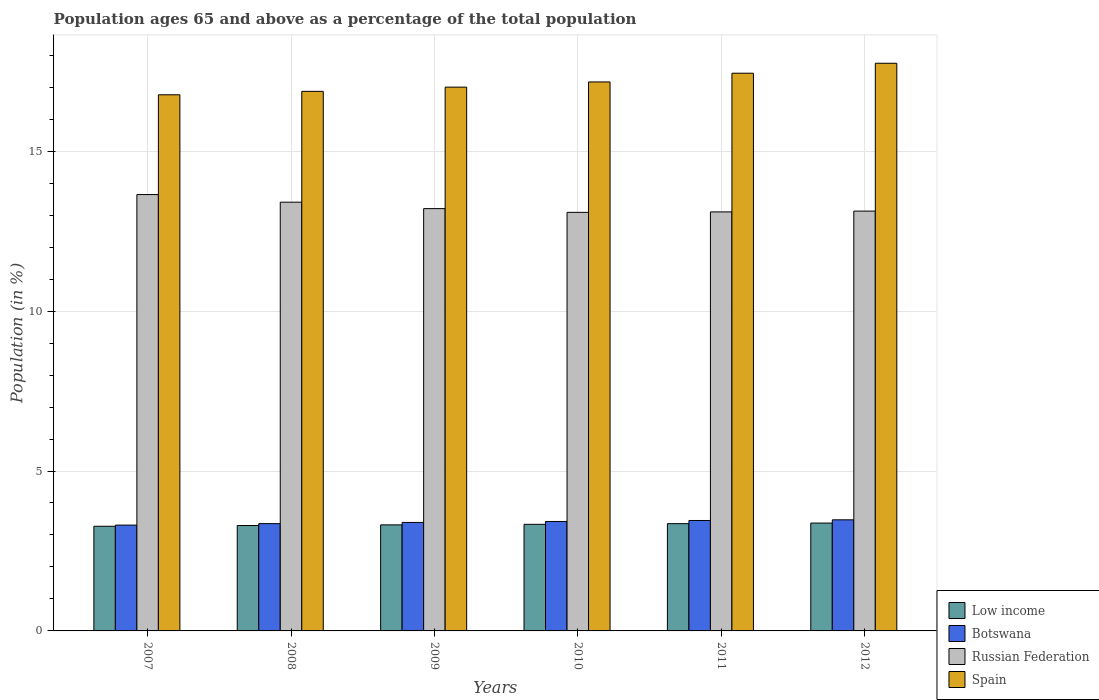How many different coloured bars are there?
Keep it short and to the point. 4. How many groups of bars are there?
Ensure brevity in your answer.  6. How many bars are there on the 5th tick from the left?
Provide a short and direct response. 4. What is the percentage of the population ages 65 and above in Spain in 2007?
Provide a short and direct response. 16.76. Across all years, what is the maximum percentage of the population ages 65 and above in Spain?
Your answer should be compact. 17.75. Across all years, what is the minimum percentage of the population ages 65 and above in Spain?
Ensure brevity in your answer.  16.76. In which year was the percentage of the population ages 65 and above in Low income maximum?
Offer a very short reply. 2012. What is the total percentage of the population ages 65 and above in Botswana in the graph?
Your answer should be very brief. 20.4. What is the difference between the percentage of the population ages 65 and above in Low income in 2007 and that in 2012?
Provide a succinct answer. -0.1. What is the difference between the percentage of the population ages 65 and above in Spain in 2010 and the percentage of the population ages 65 and above in Russian Federation in 2009?
Your answer should be very brief. 3.96. What is the average percentage of the population ages 65 and above in Spain per year?
Make the answer very short. 17.16. In the year 2008, what is the difference between the percentage of the population ages 65 and above in Russian Federation and percentage of the population ages 65 and above in Low income?
Your response must be concise. 10.11. What is the ratio of the percentage of the population ages 65 and above in Botswana in 2008 to that in 2011?
Ensure brevity in your answer.  0.97. What is the difference between the highest and the second highest percentage of the population ages 65 and above in Spain?
Make the answer very short. 0.31. What is the difference between the highest and the lowest percentage of the population ages 65 and above in Russian Federation?
Make the answer very short. 0.56. In how many years, is the percentage of the population ages 65 and above in Spain greater than the average percentage of the population ages 65 and above in Spain taken over all years?
Offer a very short reply. 3. What does the 2nd bar from the right in 2007 represents?
Give a very brief answer. Russian Federation. Is it the case that in every year, the sum of the percentage of the population ages 65 and above in Spain and percentage of the population ages 65 and above in Low income is greater than the percentage of the population ages 65 and above in Botswana?
Make the answer very short. Yes. How many legend labels are there?
Your answer should be compact. 4. How are the legend labels stacked?
Give a very brief answer. Vertical. What is the title of the graph?
Provide a succinct answer. Population ages 65 and above as a percentage of the total population. What is the Population (in %) in Low income in 2007?
Make the answer very short. 3.27. What is the Population (in %) of Botswana in 2007?
Make the answer very short. 3.31. What is the Population (in %) in Russian Federation in 2007?
Make the answer very short. 13.64. What is the Population (in %) of Spain in 2007?
Offer a terse response. 16.76. What is the Population (in %) of Low income in 2008?
Provide a succinct answer. 3.3. What is the Population (in %) in Botswana in 2008?
Provide a succinct answer. 3.35. What is the Population (in %) of Russian Federation in 2008?
Provide a succinct answer. 13.41. What is the Population (in %) of Spain in 2008?
Your answer should be very brief. 16.87. What is the Population (in %) of Low income in 2009?
Offer a terse response. 3.32. What is the Population (in %) in Botswana in 2009?
Your answer should be compact. 3.39. What is the Population (in %) in Russian Federation in 2009?
Keep it short and to the point. 13.2. What is the Population (in %) in Spain in 2009?
Your answer should be compact. 17. What is the Population (in %) of Low income in 2010?
Your answer should be compact. 3.33. What is the Population (in %) of Botswana in 2010?
Your answer should be very brief. 3.42. What is the Population (in %) in Russian Federation in 2010?
Give a very brief answer. 13.09. What is the Population (in %) in Spain in 2010?
Give a very brief answer. 17.16. What is the Population (in %) of Low income in 2011?
Provide a succinct answer. 3.35. What is the Population (in %) of Botswana in 2011?
Keep it short and to the point. 3.45. What is the Population (in %) of Russian Federation in 2011?
Your answer should be very brief. 13.1. What is the Population (in %) in Spain in 2011?
Your answer should be compact. 17.44. What is the Population (in %) in Low income in 2012?
Ensure brevity in your answer.  3.37. What is the Population (in %) in Botswana in 2012?
Your answer should be very brief. 3.47. What is the Population (in %) of Russian Federation in 2012?
Your answer should be very brief. 13.13. What is the Population (in %) of Spain in 2012?
Offer a terse response. 17.75. Across all years, what is the maximum Population (in %) of Low income?
Offer a very short reply. 3.37. Across all years, what is the maximum Population (in %) of Botswana?
Ensure brevity in your answer.  3.47. Across all years, what is the maximum Population (in %) of Russian Federation?
Offer a terse response. 13.64. Across all years, what is the maximum Population (in %) in Spain?
Your answer should be very brief. 17.75. Across all years, what is the minimum Population (in %) in Low income?
Provide a short and direct response. 3.27. Across all years, what is the minimum Population (in %) in Botswana?
Your answer should be very brief. 3.31. Across all years, what is the minimum Population (in %) of Russian Federation?
Your response must be concise. 13.09. Across all years, what is the minimum Population (in %) of Spain?
Keep it short and to the point. 16.76. What is the total Population (in %) in Low income in the graph?
Provide a succinct answer. 19.94. What is the total Population (in %) of Botswana in the graph?
Your answer should be compact. 20.4. What is the total Population (in %) of Russian Federation in the graph?
Provide a succinct answer. 79.57. What is the total Population (in %) of Spain in the graph?
Offer a terse response. 102.99. What is the difference between the Population (in %) of Low income in 2007 and that in 2008?
Your response must be concise. -0.02. What is the difference between the Population (in %) in Botswana in 2007 and that in 2008?
Ensure brevity in your answer.  -0.05. What is the difference between the Population (in %) in Russian Federation in 2007 and that in 2008?
Ensure brevity in your answer.  0.24. What is the difference between the Population (in %) of Spain in 2007 and that in 2008?
Offer a very short reply. -0.11. What is the difference between the Population (in %) of Low income in 2007 and that in 2009?
Provide a short and direct response. -0.04. What is the difference between the Population (in %) in Botswana in 2007 and that in 2009?
Offer a very short reply. -0.08. What is the difference between the Population (in %) in Russian Federation in 2007 and that in 2009?
Offer a very short reply. 0.44. What is the difference between the Population (in %) of Spain in 2007 and that in 2009?
Your answer should be compact. -0.24. What is the difference between the Population (in %) of Low income in 2007 and that in 2010?
Provide a short and direct response. -0.06. What is the difference between the Population (in %) of Botswana in 2007 and that in 2010?
Give a very brief answer. -0.11. What is the difference between the Population (in %) of Russian Federation in 2007 and that in 2010?
Make the answer very short. 0.56. What is the difference between the Population (in %) of Spain in 2007 and that in 2010?
Offer a very short reply. -0.4. What is the difference between the Population (in %) of Low income in 2007 and that in 2011?
Your response must be concise. -0.08. What is the difference between the Population (in %) in Botswana in 2007 and that in 2011?
Your response must be concise. -0.14. What is the difference between the Population (in %) of Russian Federation in 2007 and that in 2011?
Provide a short and direct response. 0.54. What is the difference between the Population (in %) in Spain in 2007 and that in 2011?
Your answer should be very brief. -0.67. What is the difference between the Population (in %) in Low income in 2007 and that in 2012?
Provide a short and direct response. -0.1. What is the difference between the Population (in %) of Botswana in 2007 and that in 2012?
Your answer should be compact. -0.17. What is the difference between the Population (in %) of Russian Federation in 2007 and that in 2012?
Give a very brief answer. 0.52. What is the difference between the Population (in %) of Spain in 2007 and that in 2012?
Offer a very short reply. -0.99. What is the difference between the Population (in %) of Low income in 2008 and that in 2009?
Provide a succinct answer. -0.02. What is the difference between the Population (in %) in Botswana in 2008 and that in 2009?
Your response must be concise. -0.04. What is the difference between the Population (in %) in Russian Federation in 2008 and that in 2009?
Provide a short and direct response. 0.2. What is the difference between the Population (in %) of Spain in 2008 and that in 2009?
Offer a very short reply. -0.13. What is the difference between the Population (in %) in Low income in 2008 and that in 2010?
Ensure brevity in your answer.  -0.04. What is the difference between the Population (in %) of Botswana in 2008 and that in 2010?
Ensure brevity in your answer.  -0.07. What is the difference between the Population (in %) of Russian Federation in 2008 and that in 2010?
Your answer should be very brief. 0.32. What is the difference between the Population (in %) of Spain in 2008 and that in 2010?
Your response must be concise. -0.29. What is the difference between the Population (in %) in Low income in 2008 and that in 2011?
Provide a succinct answer. -0.06. What is the difference between the Population (in %) of Botswana in 2008 and that in 2011?
Your response must be concise. -0.1. What is the difference between the Population (in %) of Russian Federation in 2008 and that in 2011?
Make the answer very short. 0.3. What is the difference between the Population (in %) in Spain in 2008 and that in 2011?
Provide a succinct answer. -0.57. What is the difference between the Population (in %) in Low income in 2008 and that in 2012?
Keep it short and to the point. -0.08. What is the difference between the Population (in %) in Botswana in 2008 and that in 2012?
Provide a succinct answer. -0.12. What is the difference between the Population (in %) in Russian Federation in 2008 and that in 2012?
Your answer should be compact. 0.28. What is the difference between the Population (in %) of Spain in 2008 and that in 2012?
Your response must be concise. -0.88. What is the difference between the Population (in %) of Low income in 2009 and that in 2010?
Offer a very short reply. -0.02. What is the difference between the Population (in %) in Botswana in 2009 and that in 2010?
Provide a succinct answer. -0.03. What is the difference between the Population (in %) of Russian Federation in 2009 and that in 2010?
Your answer should be compact. 0.12. What is the difference between the Population (in %) in Spain in 2009 and that in 2010?
Offer a very short reply. -0.16. What is the difference between the Population (in %) of Low income in 2009 and that in 2011?
Offer a very short reply. -0.04. What is the difference between the Population (in %) in Botswana in 2009 and that in 2011?
Your answer should be compact. -0.06. What is the difference between the Population (in %) of Russian Federation in 2009 and that in 2011?
Your answer should be compact. 0.1. What is the difference between the Population (in %) in Spain in 2009 and that in 2011?
Your answer should be very brief. -0.44. What is the difference between the Population (in %) in Low income in 2009 and that in 2012?
Ensure brevity in your answer.  -0.06. What is the difference between the Population (in %) in Botswana in 2009 and that in 2012?
Your answer should be very brief. -0.08. What is the difference between the Population (in %) in Russian Federation in 2009 and that in 2012?
Provide a short and direct response. 0.08. What is the difference between the Population (in %) of Spain in 2009 and that in 2012?
Offer a terse response. -0.75. What is the difference between the Population (in %) of Low income in 2010 and that in 2011?
Make the answer very short. -0.02. What is the difference between the Population (in %) in Botswana in 2010 and that in 2011?
Provide a short and direct response. -0.03. What is the difference between the Population (in %) of Russian Federation in 2010 and that in 2011?
Your answer should be compact. -0.01. What is the difference between the Population (in %) of Spain in 2010 and that in 2011?
Keep it short and to the point. -0.27. What is the difference between the Population (in %) in Low income in 2010 and that in 2012?
Give a very brief answer. -0.04. What is the difference between the Population (in %) of Botswana in 2010 and that in 2012?
Provide a succinct answer. -0.05. What is the difference between the Population (in %) of Russian Federation in 2010 and that in 2012?
Your answer should be compact. -0.04. What is the difference between the Population (in %) of Spain in 2010 and that in 2012?
Offer a terse response. -0.58. What is the difference between the Population (in %) of Low income in 2011 and that in 2012?
Provide a succinct answer. -0.02. What is the difference between the Population (in %) of Botswana in 2011 and that in 2012?
Make the answer very short. -0.02. What is the difference between the Population (in %) in Russian Federation in 2011 and that in 2012?
Provide a short and direct response. -0.03. What is the difference between the Population (in %) in Spain in 2011 and that in 2012?
Keep it short and to the point. -0.31. What is the difference between the Population (in %) of Low income in 2007 and the Population (in %) of Botswana in 2008?
Offer a very short reply. -0.08. What is the difference between the Population (in %) in Low income in 2007 and the Population (in %) in Russian Federation in 2008?
Provide a short and direct response. -10.13. What is the difference between the Population (in %) of Low income in 2007 and the Population (in %) of Spain in 2008?
Your answer should be very brief. -13.6. What is the difference between the Population (in %) of Botswana in 2007 and the Population (in %) of Russian Federation in 2008?
Offer a terse response. -10.1. What is the difference between the Population (in %) of Botswana in 2007 and the Population (in %) of Spain in 2008?
Ensure brevity in your answer.  -13.56. What is the difference between the Population (in %) of Russian Federation in 2007 and the Population (in %) of Spain in 2008?
Ensure brevity in your answer.  -3.23. What is the difference between the Population (in %) of Low income in 2007 and the Population (in %) of Botswana in 2009?
Give a very brief answer. -0.12. What is the difference between the Population (in %) of Low income in 2007 and the Population (in %) of Russian Federation in 2009?
Your response must be concise. -9.93. What is the difference between the Population (in %) in Low income in 2007 and the Population (in %) in Spain in 2009?
Give a very brief answer. -13.73. What is the difference between the Population (in %) in Botswana in 2007 and the Population (in %) in Russian Federation in 2009?
Offer a terse response. -9.9. What is the difference between the Population (in %) of Botswana in 2007 and the Population (in %) of Spain in 2009?
Offer a very short reply. -13.69. What is the difference between the Population (in %) of Russian Federation in 2007 and the Population (in %) of Spain in 2009?
Give a very brief answer. -3.36. What is the difference between the Population (in %) of Low income in 2007 and the Population (in %) of Botswana in 2010?
Your answer should be very brief. -0.15. What is the difference between the Population (in %) of Low income in 2007 and the Population (in %) of Russian Federation in 2010?
Your response must be concise. -9.81. What is the difference between the Population (in %) of Low income in 2007 and the Population (in %) of Spain in 2010?
Make the answer very short. -13.89. What is the difference between the Population (in %) in Botswana in 2007 and the Population (in %) in Russian Federation in 2010?
Offer a terse response. -9.78. What is the difference between the Population (in %) of Botswana in 2007 and the Population (in %) of Spain in 2010?
Make the answer very short. -13.86. What is the difference between the Population (in %) in Russian Federation in 2007 and the Population (in %) in Spain in 2010?
Your answer should be compact. -3.52. What is the difference between the Population (in %) of Low income in 2007 and the Population (in %) of Botswana in 2011?
Your answer should be compact. -0.18. What is the difference between the Population (in %) in Low income in 2007 and the Population (in %) in Russian Federation in 2011?
Your answer should be compact. -9.83. What is the difference between the Population (in %) of Low income in 2007 and the Population (in %) of Spain in 2011?
Your answer should be compact. -14.17. What is the difference between the Population (in %) of Botswana in 2007 and the Population (in %) of Russian Federation in 2011?
Your answer should be very brief. -9.79. What is the difference between the Population (in %) in Botswana in 2007 and the Population (in %) in Spain in 2011?
Offer a very short reply. -14.13. What is the difference between the Population (in %) of Russian Federation in 2007 and the Population (in %) of Spain in 2011?
Your answer should be compact. -3.79. What is the difference between the Population (in %) in Low income in 2007 and the Population (in %) in Botswana in 2012?
Give a very brief answer. -0.2. What is the difference between the Population (in %) of Low income in 2007 and the Population (in %) of Russian Federation in 2012?
Your answer should be compact. -9.85. What is the difference between the Population (in %) of Low income in 2007 and the Population (in %) of Spain in 2012?
Give a very brief answer. -14.48. What is the difference between the Population (in %) in Botswana in 2007 and the Population (in %) in Russian Federation in 2012?
Your response must be concise. -9.82. What is the difference between the Population (in %) in Botswana in 2007 and the Population (in %) in Spain in 2012?
Offer a terse response. -14.44. What is the difference between the Population (in %) in Russian Federation in 2007 and the Population (in %) in Spain in 2012?
Offer a terse response. -4.11. What is the difference between the Population (in %) in Low income in 2008 and the Population (in %) in Botswana in 2009?
Keep it short and to the point. -0.1. What is the difference between the Population (in %) in Low income in 2008 and the Population (in %) in Russian Federation in 2009?
Give a very brief answer. -9.91. What is the difference between the Population (in %) in Low income in 2008 and the Population (in %) in Spain in 2009?
Keep it short and to the point. -13.71. What is the difference between the Population (in %) of Botswana in 2008 and the Population (in %) of Russian Federation in 2009?
Offer a very short reply. -9.85. What is the difference between the Population (in %) of Botswana in 2008 and the Population (in %) of Spain in 2009?
Offer a terse response. -13.65. What is the difference between the Population (in %) of Russian Federation in 2008 and the Population (in %) of Spain in 2009?
Give a very brief answer. -3.6. What is the difference between the Population (in %) in Low income in 2008 and the Population (in %) in Botswana in 2010?
Your response must be concise. -0.13. What is the difference between the Population (in %) of Low income in 2008 and the Population (in %) of Russian Federation in 2010?
Offer a terse response. -9.79. What is the difference between the Population (in %) in Low income in 2008 and the Population (in %) in Spain in 2010?
Your answer should be very brief. -13.87. What is the difference between the Population (in %) in Botswana in 2008 and the Population (in %) in Russian Federation in 2010?
Your answer should be compact. -9.73. What is the difference between the Population (in %) in Botswana in 2008 and the Population (in %) in Spain in 2010?
Provide a short and direct response. -13.81. What is the difference between the Population (in %) in Russian Federation in 2008 and the Population (in %) in Spain in 2010?
Your response must be concise. -3.76. What is the difference between the Population (in %) of Low income in 2008 and the Population (in %) of Botswana in 2011?
Ensure brevity in your answer.  -0.16. What is the difference between the Population (in %) in Low income in 2008 and the Population (in %) in Russian Federation in 2011?
Offer a terse response. -9.81. What is the difference between the Population (in %) in Low income in 2008 and the Population (in %) in Spain in 2011?
Keep it short and to the point. -14.14. What is the difference between the Population (in %) in Botswana in 2008 and the Population (in %) in Russian Federation in 2011?
Provide a short and direct response. -9.75. What is the difference between the Population (in %) in Botswana in 2008 and the Population (in %) in Spain in 2011?
Make the answer very short. -14.08. What is the difference between the Population (in %) in Russian Federation in 2008 and the Population (in %) in Spain in 2011?
Your answer should be very brief. -4.03. What is the difference between the Population (in %) in Low income in 2008 and the Population (in %) in Botswana in 2012?
Provide a succinct answer. -0.18. What is the difference between the Population (in %) of Low income in 2008 and the Population (in %) of Russian Federation in 2012?
Make the answer very short. -9.83. What is the difference between the Population (in %) in Low income in 2008 and the Population (in %) in Spain in 2012?
Provide a short and direct response. -14.45. What is the difference between the Population (in %) in Botswana in 2008 and the Population (in %) in Russian Federation in 2012?
Offer a very short reply. -9.77. What is the difference between the Population (in %) in Botswana in 2008 and the Population (in %) in Spain in 2012?
Make the answer very short. -14.39. What is the difference between the Population (in %) of Russian Federation in 2008 and the Population (in %) of Spain in 2012?
Make the answer very short. -4.34. What is the difference between the Population (in %) of Low income in 2009 and the Population (in %) of Botswana in 2010?
Your response must be concise. -0.11. What is the difference between the Population (in %) of Low income in 2009 and the Population (in %) of Russian Federation in 2010?
Your response must be concise. -9.77. What is the difference between the Population (in %) of Low income in 2009 and the Population (in %) of Spain in 2010?
Make the answer very short. -13.85. What is the difference between the Population (in %) in Botswana in 2009 and the Population (in %) in Russian Federation in 2010?
Provide a short and direct response. -9.69. What is the difference between the Population (in %) in Botswana in 2009 and the Population (in %) in Spain in 2010?
Ensure brevity in your answer.  -13.77. What is the difference between the Population (in %) of Russian Federation in 2009 and the Population (in %) of Spain in 2010?
Provide a succinct answer. -3.96. What is the difference between the Population (in %) of Low income in 2009 and the Population (in %) of Botswana in 2011?
Your answer should be very brief. -0.14. What is the difference between the Population (in %) in Low income in 2009 and the Population (in %) in Russian Federation in 2011?
Your response must be concise. -9.79. What is the difference between the Population (in %) of Low income in 2009 and the Population (in %) of Spain in 2011?
Make the answer very short. -14.12. What is the difference between the Population (in %) of Botswana in 2009 and the Population (in %) of Russian Federation in 2011?
Make the answer very short. -9.71. What is the difference between the Population (in %) in Botswana in 2009 and the Population (in %) in Spain in 2011?
Provide a short and direct response. -14.05. What is the difference between the Population (in %) of Russian Federation in 2009 and the Population (in %) of Spain in 2011?
Give a very brief answer. -4.23. What is the difference between the Population (in %) of Low income in 2009 and the Population (in %) of Botswana in 2012?
Provide a succinct answer. -0.16. What is the difference between the Population (in %) in Low income in 2009 and the Population (in %) in Russian Federation in 2012?
Provide a short and direct response. -9.81. What is the difference between the Population (in %) of Low income in 2009 and the Population (in %) of Spain in 2012?
Make the answer very short. -14.43. What is the difference between the Population (in %) of Botswana in 2009 and the Population (in %) of Russian Federation in 2012?
Your response must be concise. -9.73. What is the difference between the Population (in %) in Botswana in 2009 and the Population (in %) in Spain in 2012?
Your answer should be compact. -14.36. What is the difference between the Population (in %) of Russian Federation in 2009 and the Population (in %) of Spain in 2012?
Make the answer very short. -4.54. What is the difference between the Population (in %) in Low income in 2010 and the Population (in %) in Botswana in 2011?
Offer a terse response. -0.12. What is the difference between the Population (in %) of Low income in 2010 and the Population (in %) of Russian Federation in 2011?
Keep it short and to the point. -9.77. What is the difference between the Population (in %) in Low income in 2010 and the Population (in %) in Spain in 2011?
Provide a succinct answer. -14.1. What is the difference between the Population (in %) in Botswana in 2010 and the Population (in %) in Russian Federation in 2011?
Offer a terse response. -9.68. What is the difference between the Population (in %) of Botswana in 2010 and the Population (in %) of Spain in 2011?
Offer a terse response. -14.02. What is the difference between the Population (in %) of Russian Federation in 2010 and the Population (in %) of Spain in 2011?
Make the answer very short. -4.35. What is the difference between the Population (in %) in Low income in 2010 and the Population (in %) in Botswana in 2012?
Your answer should be very brief. -0.14. What is the difference between the Population (in %) in Low income in 2010 and the Population (in %) in Russian Federation in 2012?
Make the answer very short. -9.79. What is the difference between the Population (in %) in Low income in 2010 and the Population (in %) in Spain in 2012?
Make the answer very short. -14.42. What is the difference between the Population (in %) of Botswana in 2010 and the Population (in %) of Russian Federation in 2012?
Make the answer very short. -9.7. What is the difference between the Population (in %) of Botswana in 2010 and the Population (in %) of Spain in 2012?
Make the answer very short. -14.33. What is the difference between the Population (in %) in Russian Federation in 2010 and the Population (in %) in Spain in 2012?
Give a very brief answer. -4.66. What is the difference between the Population (in %) of Low income in 2011 and the Population (in %) of Botswana in 2012?
Your answer should be very brief. -0.12. What is the difference between the Population (in %) in Low income in 2011 and the Population (in %) in Russian Federation in 2012?
Keep it short and to the point. -9.77. What is the difference between the Population (in %) in Low income in 2011 and the Population (in %) in Spain in 2012?
Provide a short and direct response. -14.39. What is the difference between the Population (in %) of Botswana in 2011 and the Population (in %) of Russian Federation in 2012?
Ensure brevity in your answer.  -9.67. What is the difference between the Population (in %) of Botswana in 2011 and the Population (in %) of Spain in 2012?
Your answer should be very brief. -14.3. What is the difference between the Population (in %) in Russian Federation in 2011 and the Population (in %) in Spain in 2012?
Keep it short and to the point. -4.65. What is the average Population (in %) in Low income per year?
Offer a very short reply. 3.32. What is the average Population (in %) of Botswana per year?
Your response must be concise. 3.4. What is the average Population (in %) of Russian Federation per year?
Ensure brevity in your answer.  13.26. What is the average Population (in %) of Spain per year?
Your answer should be compact. 17.16. In the year 2007, what is the difference between the Population (in %) in Low income and Population (in %) in Botswana?
Keep it short and to the point. -0.04. In the year 2007, what is the difference between the Population (in %) in Low income and Population (in %) in Russian Federation?
Your response must be concise. -10.37. In the year 2007, what is the difference between the Population (in %) in Low income and Population (in %) in Spain?
Offer a very short reply. -13.49. In the year 2007, what is the difference between the Population (in %) in Botswana and Population (in %) in Russian Federation?
Your answer should be compact. -10.34. In the year 2007, what is the difference between the Population (in %) in Botswana and Population (in %) in Spain?
Provide a succinct answer. -13.45. In the year 2007, what is the difference between the Population (in %) in Russian Federation and Population (in %) in Spain?
Your answer should be compact. -3.12. In the year 2008, what is the difference between the Population (in %) in Low income and Population (in %) in Botswana?
Offer a terse response. -0.06. In the year 2008, what is the difference between the Population (in %) in Low income and Population (in %) in Russian Federation?
Your answer should be compact. -10.11. In the year 2008, what is the difference between the Population (in %) in Low income and Population (in %) in Spain?
Give a very brief answer. -13.57. In the year 2008, what is the difference between the Population (in %) of Botswana and Population (in %) of Russian Federation?
Offer a terse response. -10.05. In the year 2008, what is the difference between the Population (in %) of Botswana and Population (in %) of Spain?
Provide a short and direct response. -13.52. In the year 2008, what is the difference between the Population (in %) of Russian Federation and Population (in %) of Spain?
Make the answer very short. -3.46. In the year 2009, what is the difference between the Population (in %) of Low income and Population (in %) of Botswana?
Keep it short and to the point. -0.08. In the year 2009, what is the difference between the Population (in %) of Low income and Population (in %) of Russian Federation?
Provide a short and direct response. -9.89. In the year 2009, what is the difference between the Population (in %) of Low income and Population (in %) of Spain?
Your response must be concise. -13.69. In the year 2009, what is the difference between the Population (in %) in Botswana and Population (in %) in Russian Federation?
Provide a short and direct response. -9.81. In the year 2009, what is the difference between the Population (in %) of Botswana and Population (in %) of Spain?
Provide a short and direct response. -13.61. In the year 2009, what is the difference between the Population (in %) in Russian Federation and Population (in %) in Spain?
Provide a short and direct response. -3.8. In the year 2010, what is the difference between the Population (in %) of Low income and Population (in %) of Botswana?
Ensure brevity in your answer.  -0.09. In the year 2010, what is the difference between the Population (in %) of Low income and Population (in %) of Russian Federation?
Provide a short and direct response. -9.75. In the year 2010, what is the difference between the Population (in %) in Low income and Population (in %) in Spain?
Give a very brief answer. -13.83. In the year 2010, what is the difference between the Population (in %) of Botswana and Population (in %) of Russian Federation?
Offer a terse response. -9.67. In the year 2010, what is the difference between the Population (in %) of Botswana and Population (in %) of Spain?
Make the answer very short. -13.74. In the year 2010, what is the difference between the Population (in %) of Russian Federation and Population (in %) of Spain?
Ensure brevity in your answer.  -4.08. In the year 2011, what is the difference between the Population (in %) in Low income and Population (in %) in Botswana?
Provide a succinct answer. -0.1. In the year 2011, what is the difference between the Population (in %) in Low income and Population (in %) in Russian Federation?
Your answer should be very brief. -9.75. In the year 2011, what is the difference between the Population (in %) in Low income and Population (in %) in Spain?
Your answer should be very brief. -14.08. In the year 2011, what is the difference between the Population (in %) in Botswana and Population (in %) in Russian Federation?
Your answer should be very brief. -9.65. In the year 2011, what is the difference between the Population (in %) of Botswana and Population (in %) of Spain?
Your response must be concise. -13.99. In the year 2011, what is the difference between the Population (in %) of Russian Federation and Population (in %) of Spain?
Offer a very short reply. -4.34. In the year 2012, what is the difference between the Population (in %) of Low income and Population (in %) of Botswana?
Provide a succinct answer. -0.1. In the year 2012, what is the difference between the Population (in %) in Low income and Population (in %) in Russian Federation?
Keep it short and to the point. -9.75. In the year 2012, what is the difference between the Population (in %) of Low income and Population (in %) of Spain?
Your response must be concise. -14.38. In the year 2012, what is the difference between the Population (in %) in Botswana and Population (in %) in Russian Federation?
Your answer should be very brief. -9.65. In the year 2012, what is the difference between the Population (in %) in Botswana and Population (in %) in Spain?
Offer a terse response. -14.28. In the year 2012, what is the difference between the Population (in %) in Russian Federation and Population (in %) in Spain?
Give a very brief answer. -4.62. What is the ratio of the Population (in %) in Low income in 2007 to that in 2008?
Your answer should be very brief. 0.99. What is the ratio of the Population (in %) in Botswana in 2007 to that in 2008?
Make the answer very short. 0.99. What is the ratio of the Population (in %) in Russian Federation in 2007 to that in 2008?
Give a very brief answer. 1.02. What is the ratio of the Population (in %) of Low income in 2007 to that in 2009?
Give a very brief answer. 0.99. What is the ratio of the Population (in %) of Botswana in 2007 to that in 2009?
Ensure brevity in your answer.  0.98. What is the ratio of the Population (in %) in Russian Federation in 2007 to that in 2009?
Your answer should be compact. 1.03. What is the ratio of the Population (in %) in Spain in 2007 to that in 2009?
Your response must be concise. 0.99. What is the ratio of the Population (in %) in Low income in 2007 to that in 2010?
Offer a very short reply. 0.98. What is the ratio of the Population (in %) in Botswana in 2007 to that in 2010?
Give a very brief answer. 0.97. What is the ratio of the Population (in %) in Russian Federation in 2007 to that in 2010?
Provide a short and direct response. 1.04. What is the ratio of the Population (in %) in Spain in 2007 to that in 2010?
Offer a very short reply. 0.98. What is the ratio of the Population (in %) of Low income in 2007 to that in 2011?
Give a very brief answer. 0.98. What is the ratio of the Population (in %) of Botswana in 2007 to that in 2011?
Offer a terse response. 0.96. What is the ratio of the Population (in %) in Russian Federation in 2007 to that in 2011?
Offer a terse response. 1.04. What is the ratio of the Population (in %) in Spain in 2007 to that in 2011?
Keep it short and to the point. 0.96. What is the ratio of the Population (in %) of Low income in 2007 to that in 2012?
Offer a very short reply. 0.97. What is the ratio of the Population (in %) in Botswana in 2007 to that in 2012?
Keep it short and to the point. 0.95. What is the ratio of the Population (in %) in Russian Federation in 2007 to that in 2012?
Keep it short and to the point. 1.04. What is the ratio of the Population (in %) in Spain in 2007 to that in 2012?
Your answer should be very brief. 0.94. What is the ratio of the Population (in %) of Russian Federation in 2008 to that in 2009?
Ensure brevity in your answer.  1.02. What is the ratio of the Population (in %) in Botswana in 2008 to that in 2010?
Give a very brief answer. 0.98. What is the ratio of the Population (in %) in Russian Federation in 2008 to that in 2010?
Offer a terse response. 1.02. What is the ratio of the Population (in %) of Spain in 2008 to that in 2010?
Provide a short and direct response. 0.98. What is the ratio of the Population (in %) in Low income in 2008 to that in 2011?
Provide a succinct answer. 0.98. What is the ratio of the Population (in %) in Botswana in 2008 to that in 2011?
Keep it short and to the point. 0.97. What is the ratio of the Population (in %) of Russian Federation in 2008 to that in 2011?
Offer a very short reply. 1.02. What is the ratio of the Population (in %) of Spain in 2008 to that in 2011?
Offer a very short reply. 0.97. What is the ratio of the Population (in %) in Low income in 2008 to that in 2012?
Give a very brief answer. 0.98. What is the ratio of the Population (in %) of Botswana in 2008 to that in 2012?
Give a very brief answer. 0.97. What is the ratio of the Population (in %) in Russian Federation in 2008 to that in 2012?
Provide a succinct answer. 1.02. What is the ratio of the Population (in %) of Spain in 2008 to that in 2012?
Make the answer very short. 0.95. What is the ratio of the Population (in %) of Low income in 2009 to that in 2010?
Ensure brevity in your answer.  0.99. What is the ratio of the Population (in %) of Botswana in 2009 to that in 2010?
Give a very brief answer. 0.99. What is the ratio of the Population (in %) in Russian Federation in 2009 to that in 2010?
Keep it short and to the point. 1.01. What is the ratio of the Population (in %) of Spain in 2009 to that in 2010?
Your answer should be compact. 0.99. What is the ratio of the Population (in %) of Low income in 2009 to that in 2011?
Make the answer very short. 0.99. What is the ratio of the Population (in %) of Botswana in 2009 to that in 2011?
Give a very brief answer. 0.98. What is the ratio of the Population (in %) of Russian Federation in 2009 to that in 2011?
Your answer should be very brief. 1.01. What is the ratio of the Population (in %) of Low income in 2009 to that in 2012?
Your response must be concise. 0.98. What is the ratio of the Population (in %) of Botswana in 2009 to that in 2012?
Offer a very short reply. 0.98. What is the ratio of the Population (in %) in Russian Federation in 2009 to that in 2012?
Your answer should be very brief. 1.01. What is the ratio of the Population (in %) of Spain in 2009 to that in 2012?
Give a very brief answer. 0.96. What is the ratio of the Population (in %) in Botswana in 2010 to that in 2011?
Provide a succinct answer. 0.99. What is the ratio of the Population (in %) in Russian Federation in 2010 to that in 2011?
Make the answer very short. 1. What is the ratio of the Population (in %) in Spain in 2010 to that in 2011?
Keep it short and to the point. 0.98. What is the ratio of the Population (in %) of Low income in 2010 to that in 2012?
Offer a very short reply. 0.99. What is the ratio of the Population (in %) of Botswana in 2010 to that in 2012?
Ensure brevity in your answer.  0.99. What is the ratio of the Population (in %) of Spain in 2010 to that in 2012?
Your answer should be compact. 0.97. What is the ratio of the Population (in %) in Low income in 2011 to that in 2012?
Give a very brief answer. 0.99. What is the ratio of the Population (in %) in Botswana in 2011 to that in 2012?
Keep it short and to the point. 0.99. What is the ratio of the Population (in %) in Spain in 2011 to that in 2012?
Your answer should be very brief. 0.98. What is the difference between the highest and the second highest Population (in %) of Low income?
Provide a short and direct response. 0.02. What is the difference between the highest and the second highest Population (in %) in Botswana?
Your answer should be very brief. 0.02. What is the difference between the highest and the second highest Population (in %) in Russian Federation?
Offer a terse response. 0.24. What is the difference between the highest and the second highest Population (in %) of Spain?
Keep it short and to the point. 0.31. What is the difference between the highest and the lowest Population (in %) of Low income?
Provide a succinct answer. 0.1. What is the difference between the highest and the lowest Population (in %) of Botswana?
Provide a succinct answer. 0.17. What is the difference between the highest and the lowest Population (in %) of Russian Federation?
Your answer should be very brief. 0.56. What is the difference between the highest and the lowest Population (in %) in Spain?
Provide a short and direct response. 0.99. 